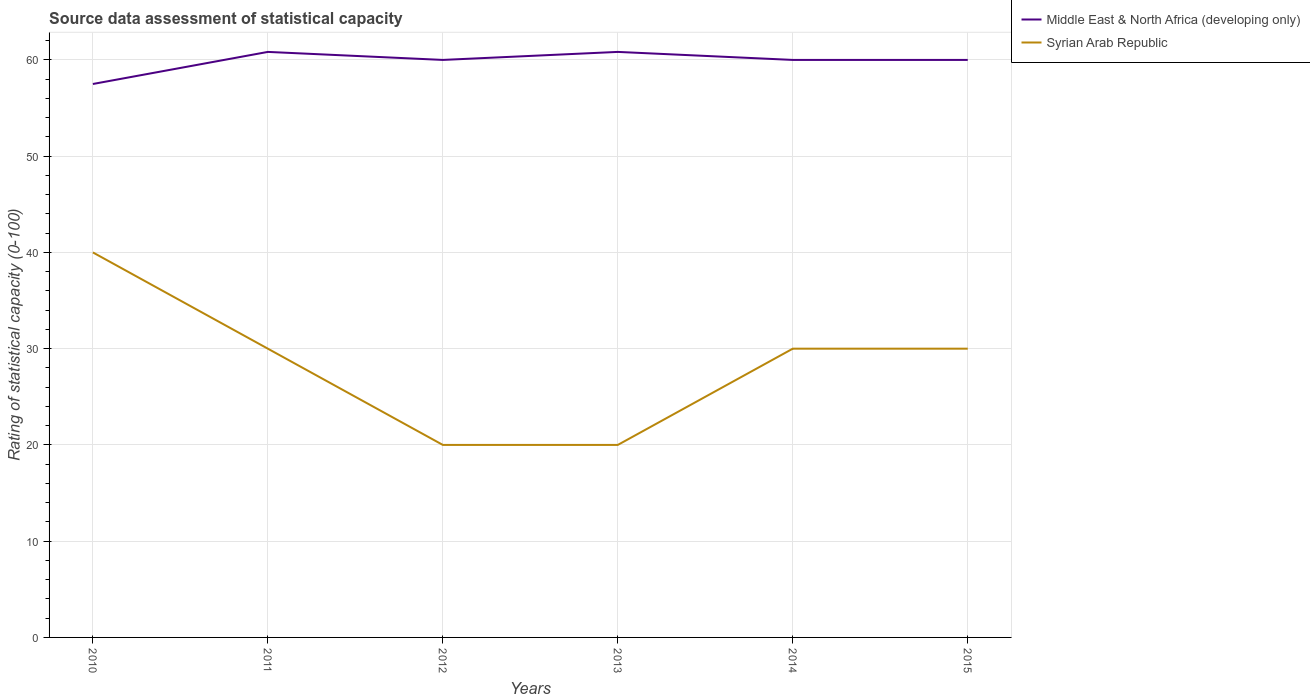How many different coloured lines are there?
Your answer should be very brief. 2. Across all years, what is the maximum rating of statistical capacity in Syrian Arab Republic?
Give a very brief answer. 20. What is the difference between the highest and the second highest rating of statistical capacity in Middle East & North Africa (developing only)?
Provide a short and direct response. 3.33. What is the difference between the highest and the lowest rating of statistical capacity in Middle East & North Africa (developing only)?
Your answer should be compact. 5. Where does the legend appear in the graph?
Your answer should be very brief. Top right. How many legend labels are there?
Your response must be concise. 2. How are the legend labels stacked?
Provide a succinct answer. Vertical. What is the title of the graph?
Give a very brief answer. Source data assessment of statistical capacity. Does "Fragile and conflict affected situations" appear as one of the legend labels in the graph?
Your answer should be compact. No. What is the label or title of the X-axis?
Provide a short and direct response. Years. What is the label or title of the Y-axis?
Give a very brief answer. Rating of statistical capacity (0-100). What is the Rating of statistical capacity (0-100) in Middle East & North Africa (developing only) in 2010?
Give a very brief answer. 57.5. What is the Rating of statistical capacity (0-100) of Syrian Arab Republic in 2010?
Your response must be concise. 40. What is the Rating of statistical capacity (0-100) in Middle East & North Africa (developing only) in 2011?
Provide a succinct answer. 60.83. What is the Rating of statistical capacity (0-100) in Syrian Arab Republic in 2011?
Give a very brief answer. 30. What is the Rating of statistical capacity (0-100) in Middle East & North Africa (developing only) in 2013?
Offer a terse response. 60.83. What is the Rating of statistical capacity (0-100) of Middle East & North Africa (developing only) in 2014?
Your response must be concise. 60. What is the Rating of statistical capacity (0-100) in Syrian Arab Republic in 2014?
Make the answer very short. 30. What is the Rating of statistical capacity (0-100) of Middle East & North Africa (developing only) in 2015?
Your response must be concise. 60. Across all years, what is the maximum Rating of statistical capacity (0-100) in Middle East & North Africa (developing only)?
Ensure brevity in your answer.  60.83. Across all years, what is the maximum Rating of statistical capacity (0-100) in Syrian Arab Republic?
Offer a terse response. 40. Across all years, what is the minimum Rating of statistical capacity (0-100) in Middle East & North Africa (developing only)?
Provide a succinct answer. 57.5. What is the total Rating of statistical capacity (0-100) of Middle East & North Africa (developing only) in the graph?
Offer a terse response. 359.17. What is the total Rating of statistical capacity (0-100) in Syrian Arab Republic in the graph?
Provide a short and direct response. 170. What is the difference between the Rating of statistical capacity (0-100) of Middle East & North Africa (developing only) in 2010 and that in 2011?
Ensure brevity in your answer.  -3.33. What is the difference between the Rating of statistical capacity (0-100) of Middle East & North Africa (developing only) in 2010 and that in 2012?
Provide a short and direct response. -2.5. What is the difference between the Rating of statistical capacity (0-100) of Syrian Arab Republic in 2010 and that in 2013?
Make the answer very short. 20. What is the difference between the Rating of statistical capacity (0-100) of Middle East & North Africa (developing only) in 2010 and that in 2014?
Your answer should be compact. -2.5. What is the difference between the Rating of statistical capacity (0-100) in Syrian Arab Republic in 2010 and that in 2015?
Offer a terse response. 10. What is the difference between the Rating of statistical capacity (0-100) of Middle East & North Africa (developing only) in 2011 and that in 2012?
Your answer should be very brief. 0.83. What is the difference between the Rating of statistical capacity (0-100) in Syrian Arab Republic in 2011 and that in 2013?
Your answer should be very brief. 10. What is the difference between the Rating of statistical capacity (0-100) in Middle East & North Africa (developing only) in 2011 and that in 2014?
Your answer should be compact. 0.83. What is the difference between the Rating of statistical capacity (0-100) in Syrian Arab Republic in 2012 and that in 2013?
Ensure brevity in your answer.  0. What is the difference between the Rating of statistical capacity (0-100) of Syrian Arab Republic in 2012 and that in 2014?
Keep it short and to the point. -10. What is the difference between the Rating of statistical capacity (0-100) of Middle East & North Africa (developing only) in 2012 and that in 2015?
Offer a terse response. 0. What is the difference between the Rating of statistical capacity (0-100) in Syrian Arab Republic in 2012 and that in 2015?
Your response must be concise. -10. What is the difference between the Rating of statistical capacity (0-100) in Middle East & North Africa (developing only) in 2013 and that in 2015?
Ensure brevity in your answer.  0.83. What is the difference between the Rating of statistical capacity (0-100) in Syrian Arab Republic in 2013 and that in 2015?
Offer a very short reply. -10. What is the difference between the Rating of statistical capacity (0-100) in Middle East & North Africa (developing only) in 2010 and the Rating of statistical capacity (0-100) in Syrian Arab Republic in 2012?
Keep it short and to the point. 37.5. What is the difference between the Rating of statistical capacity (0-100) in Middle East & North Africa (developing only) in 2010 and the Rating of statistical capacity (0-100) in Syrian Arab Republic in 2013?
Offer a very short reply. 37.5. What is the difference between the Rating of statistical capacity (0-100) in Middle East & North Africa (developing only) in 2011 and the Rating of statistical capacity (0-100) in Syrian Arab Republic in 2012?
Make the answer very short. 40.83. What is the difference between the Rating of statistical capacity (0-100) of Middle East & North Africa (developing only) in 2011 and the Rating of statistical capacity (0-100) of Syrian Arab Republic in 2013?
Provide a short and direct response. 40.83. What is the difference between the Rating of statistical capacity (0-100) in Middle East & North Africa (developing only) in 2011 and the Rating of statistical capacity (0-100) in Syrian Arab Republic in 2014?
Provide a short and direct response. 30.83. What is the difference between the Rating of statistical capacity (0-100) in Middle East & North Africa (developing only) in 2011 and the Rating of statistical capacity (0-100) in Syrian Arab Republic in 2015?
Your answer should be compact. 30.83. What is the difference between the Rating of statistical capacity (0-100) in Middle East & North Africa (developing only) in 2012 and the Rating of statistical capacity (0-100) in Syrian Arab Republic in 2013?
Your response must be concise. 40. What is the difference between the Rating of statistical capacity (0-100) of Middle East & North Africa (developing only) in 2012 and the Rating of statistical capacity (0-100) of Syrian Arab Republic in 2015?
Ensure brevity in your answer.  30. What is the difference between the Rating of statistical capacity (0-100) of Middle East & North Africa (developing only) in 2013 and the Rating of statistical capacity (0-100) of Syrian Arab Republic in 2014?
Your response must be concise. 30.83. What is the difference between the Rating of statistical capacity (0-100) in Middle East & North Africa (developing only) in 2013 and the Rating of statistical capacity (0-100) in Syrian Arab Republic in 2015?
Your response must be concise. 30.83. What is the average Rating of statistical capacity (0-100) of Middle East & North Africa (developing only) per year?
Offer a very short reply. 59.86. What is the average Rating of statistical capacity (0-100) of Syrian Arab Republic per year?
Offer a very short reply. 28.33. In the year 2011, what is the difference between the Rating of statistical capacity (0-100) of Middle East & North Africa (developing only) and Rating of statistical capacity (0-100) of Syrian Arab Republic?
Ensure brevity in your answer.  30.83. In the year 2012, what is the difference between the Rating of statistical capacity (0-100) of Middle East & North Africa (developing only) and Rating of statistical capacity (0-100) of Syrian Arab Republic?
Your answer should be compact. 40. In the year 2013, what is the difference between the Rating of statistical capacity (0-100) of Middle East & North Africa (developing only) and Rating of statistical capacity (0-100) of Syrian Arab Republic?
Give a very brief answer. 40.83. In the year 2015, what is the difference between the Rating of statistical capacity (0-100) of Middle East & North Africa (developing only) and Rating of statistical capacity (0-100) of Syrian Arab Republic?
Your answer should be very brief. 30. What is the ratio of the Rating of statistical capacity (0-100) of Middle East & North Africa (developing only) in 2010 to that in 2011?
Provide a succinct answer. 0.95. What is the ratio of the Rating of statistical capacity (0-100) in Middle East & North Africa (developing only) in 2010 to that in 2013?
Keep it short and to the point. 0.95. What is the ratio of the Rating of statistical capacity (0-100) in Syrian Arab Republic in 2010 to that in 2015?
Offer a very short reply. 1.33. What is the ratio of the Rating of statistical capacity (0-100) in Middle East & North Africa (developing only) in 2011 to that in 2012?
Your response must be concise. 1.01. What is the ratio of the Rating of statistical capacity (0-100) of Middle East & North Africa (developing only) in 2011 to that in 2013?
Make the answer very short. 1. What is the ratio of the Rating of statistical capacity (0-100) of Syrian Arab Republic in 2011 to that in 2013?
Provide a short and direct response. 1.5. What is the ratio of the Rating of statistical capacity (0-100) in Middle East & North Africa (developing only) in 2011 to that in 2014?
Your response must be concise. 1.01. What is the ratio of the Rating of statistical capacity (0-100) in Syrian Arab Republic in 2011 to that in 2014?
Keep it short and to the point. 1. What is the ratio of the Rating of statistical capacity (0-100) of Middle East & North Africa (developing only) in 2011 to that in 2015?
Provide a succinct answer. 1.01. What is the ratio of the Rating of statistical capacity (0-100) of Syrian Arab Republic in 2011 to that in 2015?
Offer a very short reply. 1. What is the ratio of the Rating of statistical capacity (0-100) in Middle East & North Africa (developing only) in 2012 to that in 2013?
Your response must be concise. 0.99. What is the ratio of the Rating of statistical capacity (0-100) of Middle East & North Africa (developing only) in 2012 to that in 2015?
Keep it short and to the point. 1. What is the ratio of the Rating of statistical capacity (0-100) in Syrian Arab Republic in 2012 to that in 2015?
Your response must be concise. 0.67. What is the ratio of the Rating of statistical capacity (0-100) of Middle East & North Africa (developing only) in 2013 to that in 2014?
Your response must be concise. 1.01. What is the ratio of the Rating of statistical capacity (0-100) of Middle East & North Africa (developing only) in 2013 to that in 2015?
Make the answer very short. 1.01. What is the ratio of the Rating of statistical capacity (0-100) in Syrian Arab Republic in 2013 to that in 2015?
Keep it short and to the point. 0.67. What is the ratio of the Rating of statistical capacity (0-100) in Middle East & North Africa (developing only) in 2014 to that in 2015?
Keep it short and to the point. 1. What is the difference between the highest and the second highest Rating of statistical capacity (0-100) in Middle East & North Africa (developing only)?
Provide a succinct answer. 0. What is the difference between the highest and the second highest Rating of statistical capacity (0-100) of Syrian Arab Republic?
Keep it short and to the point. 10. What is the difference between the highest and the lowest Rating of statistical capacity (0-100) in Middle East & North Africa (developing only)?
Your answer should be very brief. 3.33. What is the difference between the highest and the lowest Rating of statistical capacity (0-100) of Syrian Arab Republic?
Provide a short and direct response. 20. 